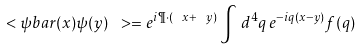Convert formula to latex. <formula><loc_0><loc_0><loc_500><loc_500>\ < \psi b a r ( x ) \psi ( y ) \ > = e ^ { i \P \cdot ( \ x + \ y ) } \int \, d ^ { 4 } q \, e ^ { - i q ( x - y ) } f ( q )</formula> 